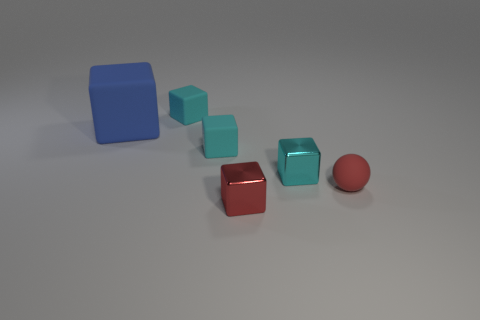Subtract all big blue matte cubes. How many cubes are left? 4 Subtract all blue cylinders. How many cyan blocks are left? 3 Subtract all blue blocks. How many blocks are left? 4 Add 1 red objects. How many objects exist? 7 Subtract all blocks. How many objects are left? 1 Subtract 0 gray cylinders. How many objects are left? 6 Subtract all blue blocks. Subtract all blue balls. How many blocks are left? 4 Subtract all big blue rubber things. Subtract all metal cubes. How many objects are left? 3 Add 1 small cyan metallic things. How many small cyan metallic things are left? 2 Add 2 tiny blocks. How many tiny blocks exist? 6 